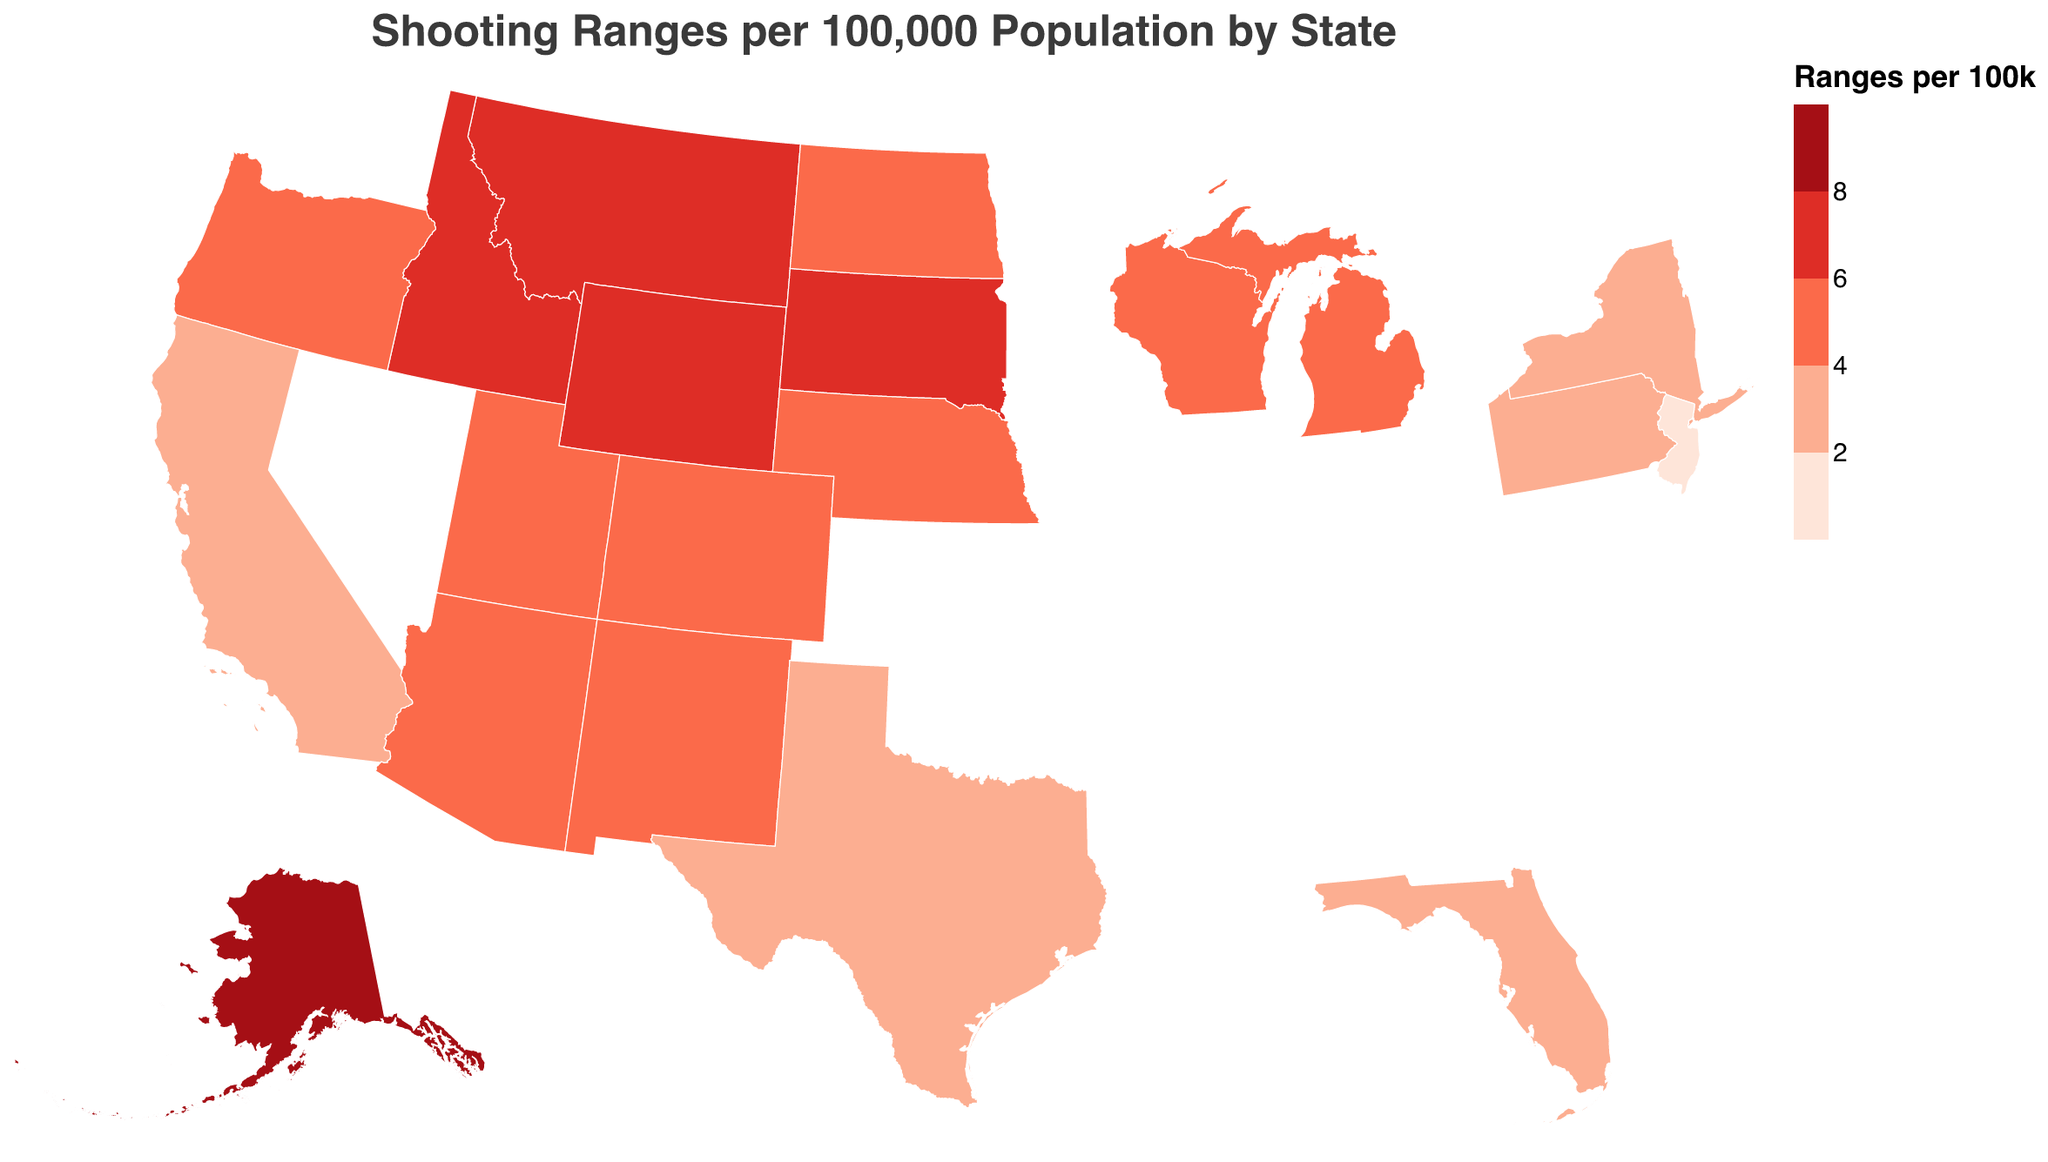Which state has the highest number of shooting ranges per 100,000 population? The title of the figure indicates that it shows shooting ranges per 100,000 population by state. From the color gradient, Alaska is the darkest color indicating the highest value. The tooltip also confirms Alaska with 8.2 shooting ranges per 100k as the highest.
Answer: Alaska How many states have a shooting range density higher than 6 per 100,000 population? From the color gradient legend, states with ranges per 100k > 6 are represented by the darkest and second darkest shades. The states with these shades are Alaska, Montana, Idaho, Wyoming, and South Dakota.
Answer: 5 Which state has the most shooting ranges and how many does it have? The tooltip provides total ranges for each state. The state with the highest total ranges is California with 1145 ranges.
Answer: California, 1145 Compare the shooting range density of Texas and Florida. Which has higher? By examining the tooltip or the color intensity, Texas has 3.7 ranges per 100k and Florida has 3.5 ranges per 100k. Hence, Texas has a higher shooting range density.
Answer: Texas What's the rank of Utah in terms of shooting range density? By listing states based on the "Ranges_Per_100k" value, we see that Utah, with 5.5 ranges per 100k, ranks 7th.
Answer: 7th What's the average shooting range density (ranges per 100k) for the states shown on the plot? Summing the ranges per 100k for all states and dividing by the number of states: (8.2 + 7.5 + 6.9 + 6.7 + 6.1 + 5.8 + 5.5 + 5.3 + 5.1 + 4.9 + 4.7 + 4.5 + 4.3 + 4.1 + 3.9 + 3.7 + 3.5 + 2.9 + 2.3 + 1.8)/20 = 4.76
Answer: 4.76 What color represents states with 4 to 6 shooting ranges per 100,000 population? According to the color scale, ranges per 100k between 4 and 6 are represented by the second lightest shade, which is a shade of red, almost pink.
Answer: Light red Is there a visual trend for states with the lowest per capita shooting range densities? States with the lowest densities (lightest shades) are located on the East Coast, suggesting that eastern states tend to have fewer ranges per capita compared to western states.
Answer: East Coast trend Why might Alaska have a high shooting range density despite a small population? Alaska’s small population (731,545) combined with 60 shooting ranges results in a high per capita density. Remote locations and community shooting necessities could contribute to a higher density in such areas.
Answer: Small population, remote locations 